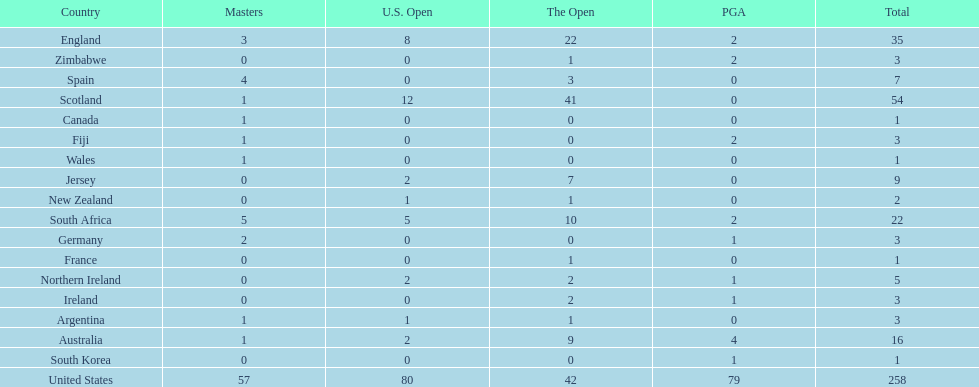What countries in the championship were from africa? South Africa, Zimbabwe. Which of these counteries had the least championship golfers Zimbabwe. 